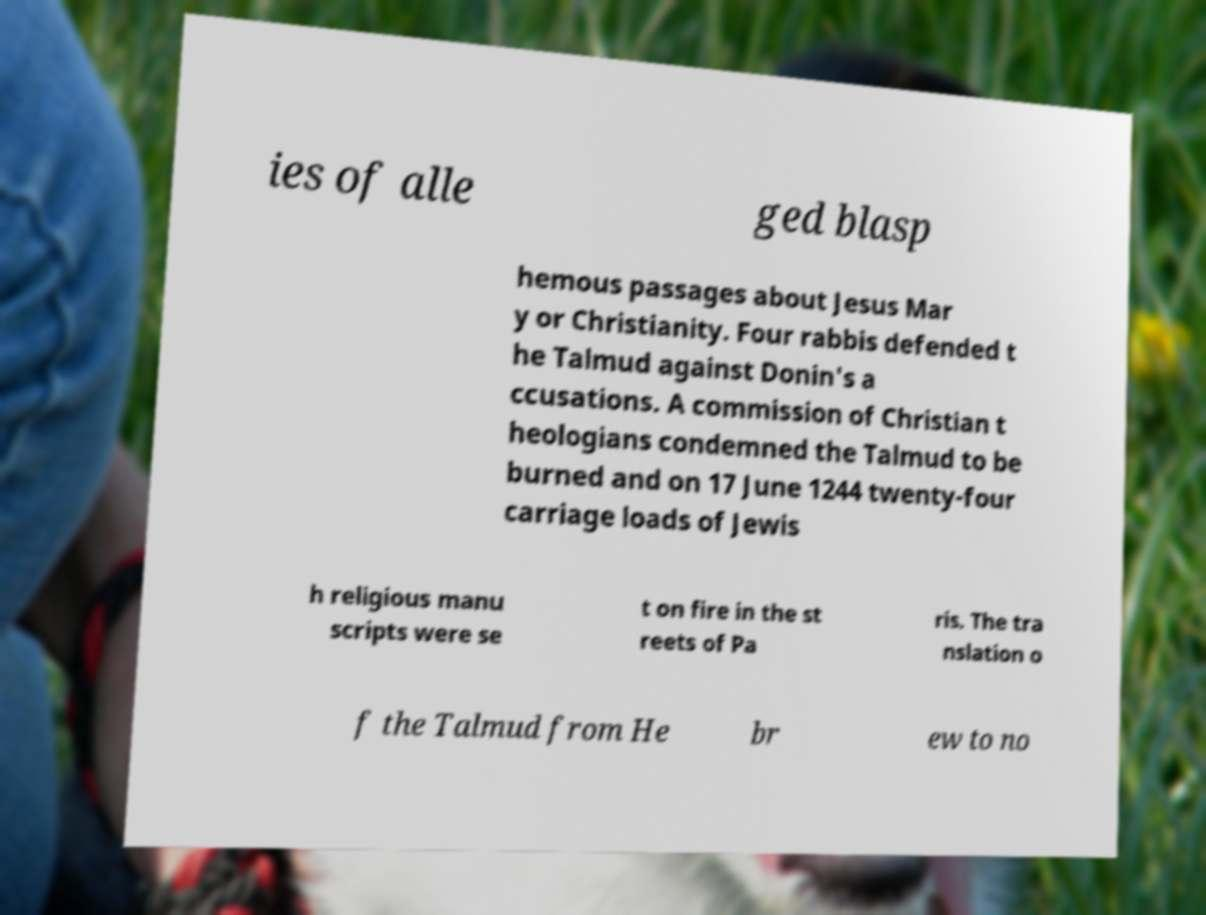What messages or text are displayed in this image? I need them in a readable, typed format. ies of alle ged blasp hemous passages about Jesus Mar y or Christianity. Four rabbis defended t he Talmud against Donin's a ccusations. A commission of Christian t heologians condemned the Talmud to be burned and on 17 June 1244 twenty-four carriage loads of Jewis h religious manu scripts were se t on fire in the st reets of Pa ris. The tra nslation o f the Talmud from He br ew to no 